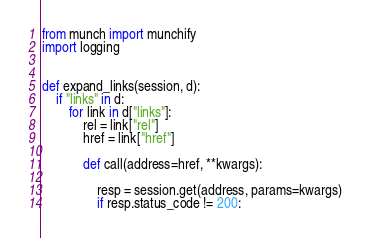Convert code to text. <code><loc_0><loc_0><loc_500><loc_500><_Python_>from munch import munchify
import logging


def expand_links(session, d):
    if "links" in d:
        for link in d["links"]:
            rel = link["rel"]
            href = link["href"]

            def call(address=href, **kwargs):

                resp = session.get(address, params=kwargs)
                if resp.status_code != 200:</code> 